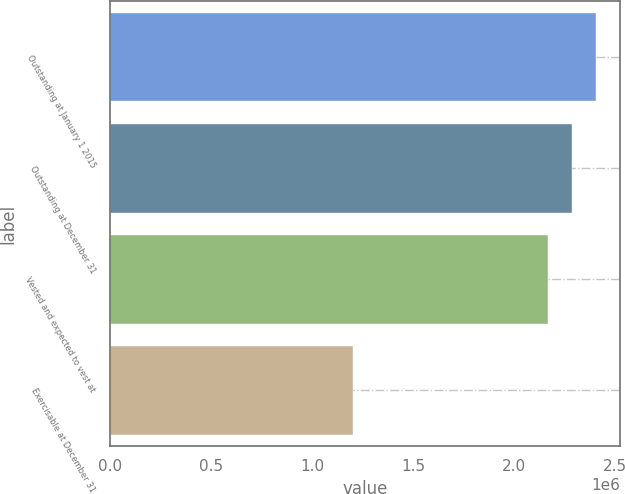Convert chart. <chart><loc_0><loc_0><loc_500><loc_500><bar_chart><fcel>Outstanding at January 1 2015<fcel>Outstanding at December 31<fcel>Vested and expected to vest at<fcel>Exercisable at December 31<nl><fcel>2.40447e+06<fcel>2.2868e+06<fcel>2.16913e+06<fcel>1.20189e+06<nl></chart> 